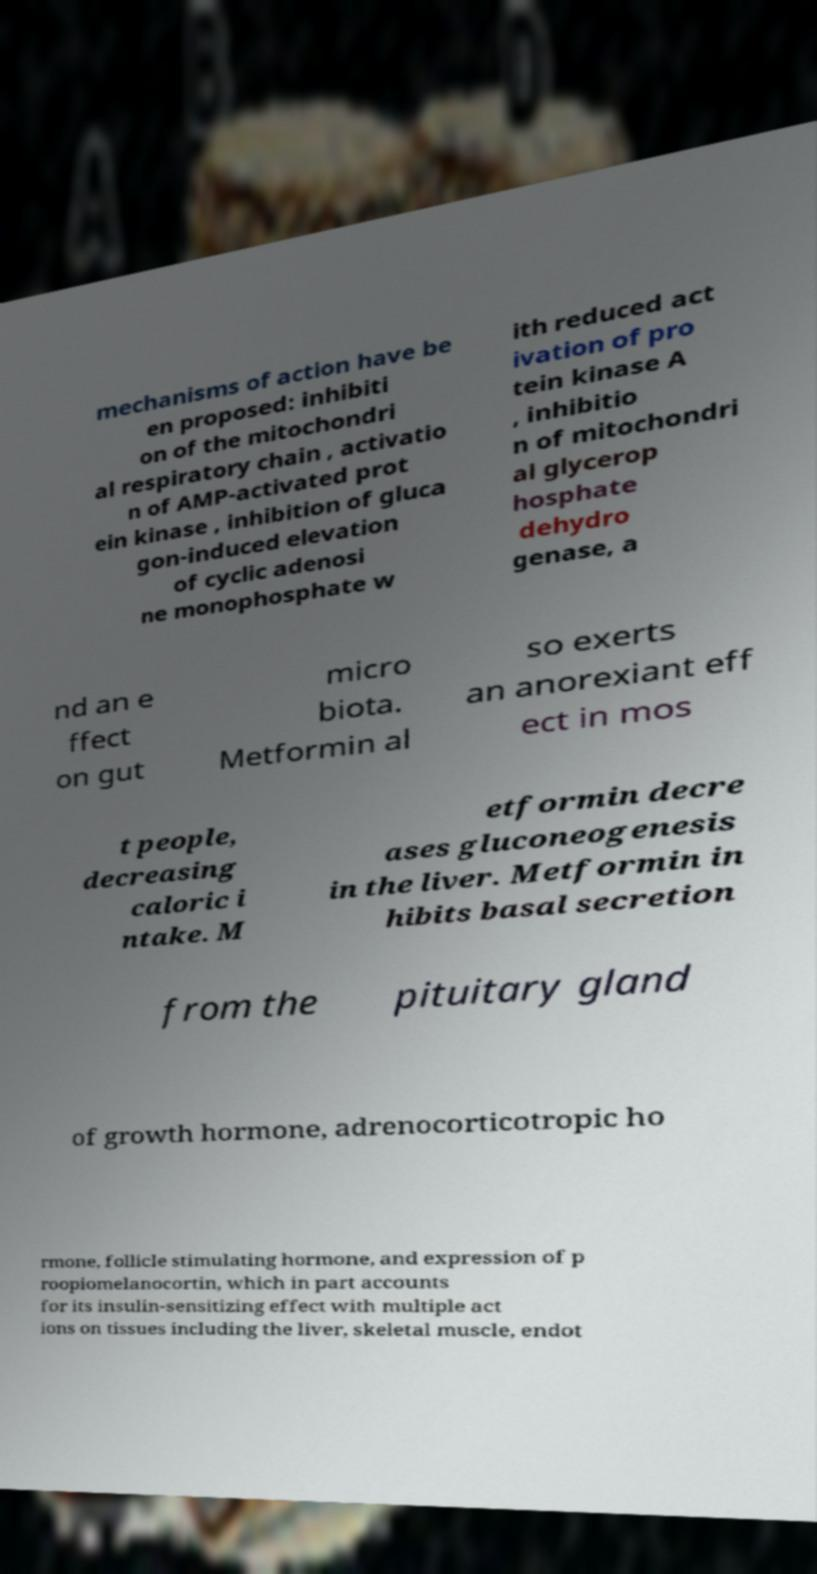Could you assist in decoding the text presented in this image and type it out clearly? mechanisms of action have be en proposed: inhibiti on of the mitochondri al respiratory chain , activatio n of AMP-activated prot ein kinase , inhibition of gluca gon-induced elevation of cyclic adenosi ne monophosphate w ith reduced act ivation of pro tein kinase A , inhibitio n of mitochondri al glycerop hosphate dehydro genase, a nd an e ffect on gut micro biota. Metformin al so exerts an anorexiant eff ect in mos t people, decreasing caloric i ntake. M etformin decre ases gluconeogenesis in the liver. Metformin in hibits basal secretion from the pituitary gland of growth hormone, adrenocorticotropic ho rmone, follicle stimulating hormone, and expression of p roopiomelanocortin, which in part accounts for its insulin-sensitizing effect with multiple act ions on tissues including the liver, skeletal muscle, endot 